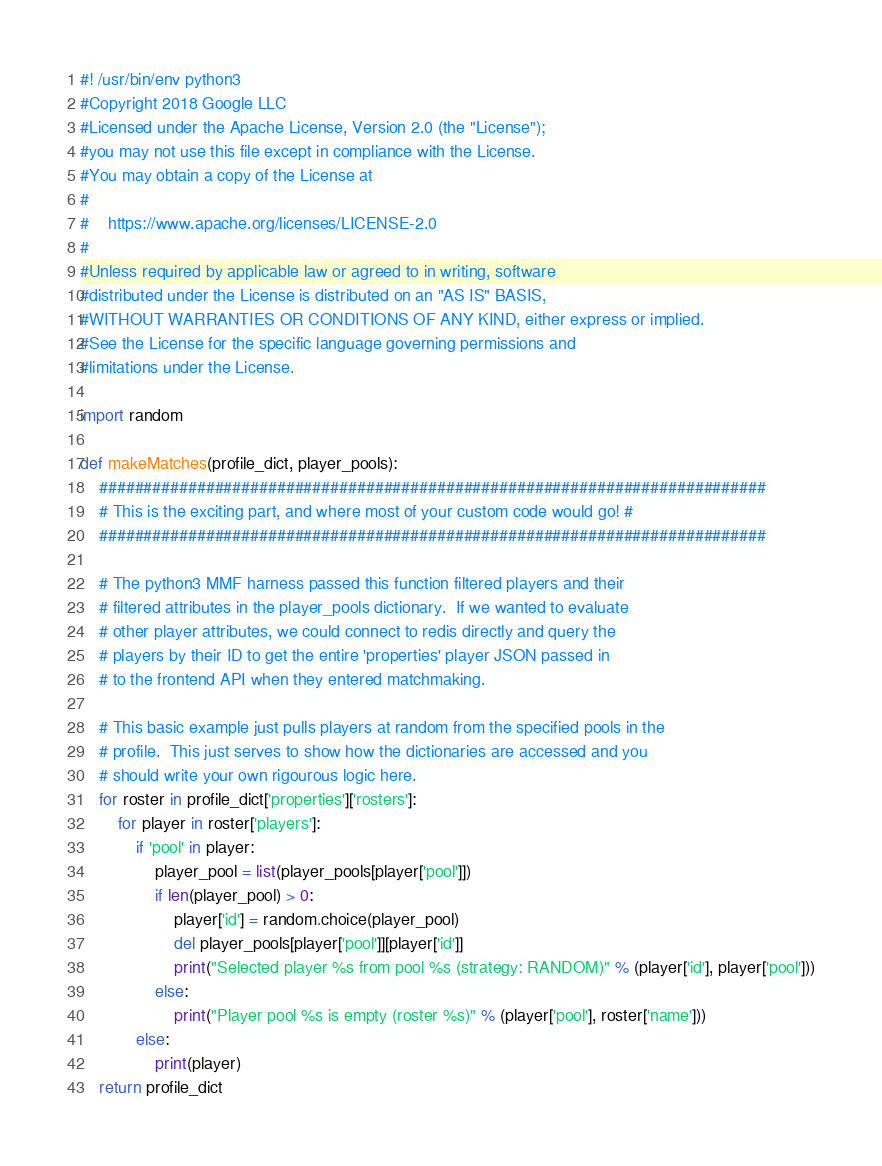Convert code to text. <code><loc_0><loc_0><loc_500><loc_500><_Python_>#! /usr/bin/env python3
#Copyright 2018 Google LLC
#Licensed under the Apache License, Version 2.0 (the "License");
#you may not use this file except in compliance with the License.
#You may obtain a copy of the License at
#
#    https://www.apache.org/licenses/LICENSE-2.0
#
#Unless required by applicable law or agreed to in writing, software
#distributed under the License is distributed on an "AS IS" BASIS,
#WITHOUT WARRANTIES OR CONDITIONS OF ANY KIND, either express or implied.
#See the License for the specific language governing permissions and
#limitations under the License.

import random

def makeMatches(profile_dict, player_pools):
    ###########################################################################
    # This is the exciting part, and where most of your custom code would go! #
    ###########################################################################

    # The python3 MMF harness passed this function filtered players and their
    # filtered attributes in the player_pools dictionary.  If we wanted to evaluate
    # other player attributes, we could connect to redis directly and query the
    # players by their ID to get the entire 'properties' player JSON passed in
    # to the frontend API when they entered matchmaking.

    # This basic example just pulls players at random from the specified pools in the 
    # profile.  This just serves to show how the dictionaries are accessed and you 
    # should write your own rigourous logic here.
    for roster in profile_dict['properties']['rosters']:
        for player in roster['players']:
            if 'pool' in player:
                player_pool = list(player_pools[player['pool']])
                if len(player_pool) > 0:
                    player['id'] = random.choice(player_pool)
                    del player_pools[player['pool']][player['id']]
                    print("Selected player %s from pool %s (strategy: RANDOM)" % (player['id'], player['pool']))
                else:
                    print("Player pool %s is empty (roster %s)" % (player['pool'], roster['name']))
            else:
                print(player)
    return profile_dict
</code> 